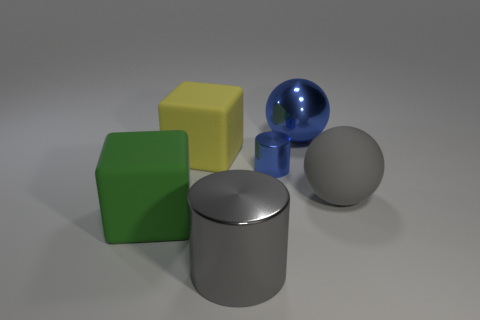Add 1 matte things. How many objects exist? 7 Subtract all blocks. How many objects are left? 4 Add 6 blue shiny cylinders. How many blue shiny cylinders are left? 7 Add 2 blue cylinders. How many blue cylinders exist? 3 Subtract 0 purple spheres. How many objects are left? 6 Subtract all blue rubber things. Subtract all large blue objects. How many objects are left? 5 